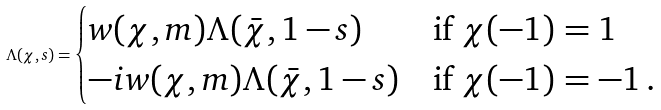<formula> <loc_0><loc_0><loc_500><loc_500>\Lambda ( \chi , s ) = \begin{cases} w ( \chi , m ) \Lambda ( \bar { \chi } , 1 - s ) & \text {if $\chi(-1)=1$} \\ - i w ( \chi , m ) \Lambda ( \bar { \chi } , 1 - s ) & \text {if $\chi(-1)=-1$\,.} \end{cases}</formula> 